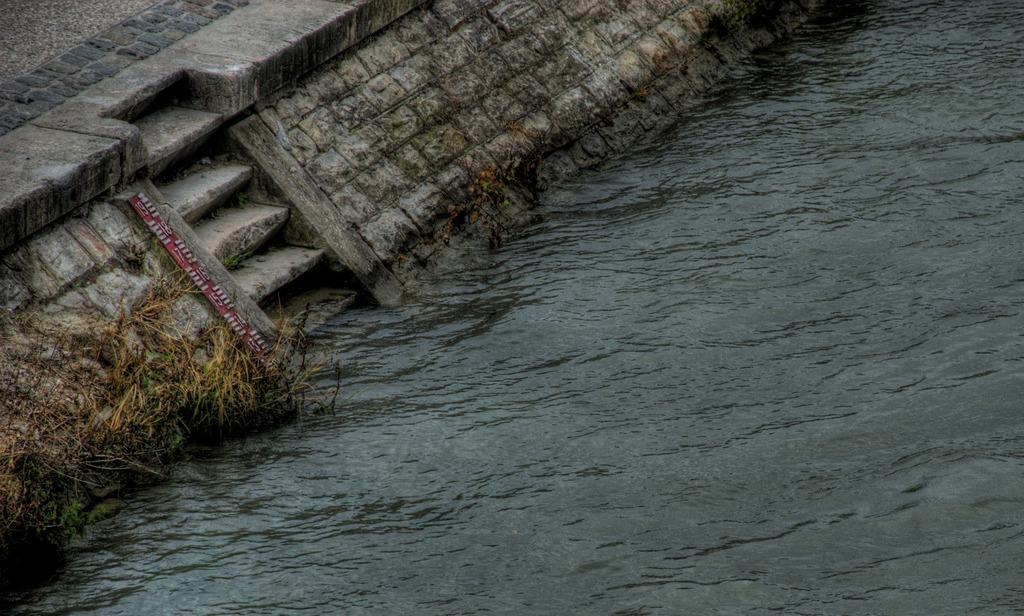Please provide a concise description of this image. In this image I can see the water, some grass which is brown and green in color, few stairs and the ground. I can see a measuring scale which is red and white in color. 